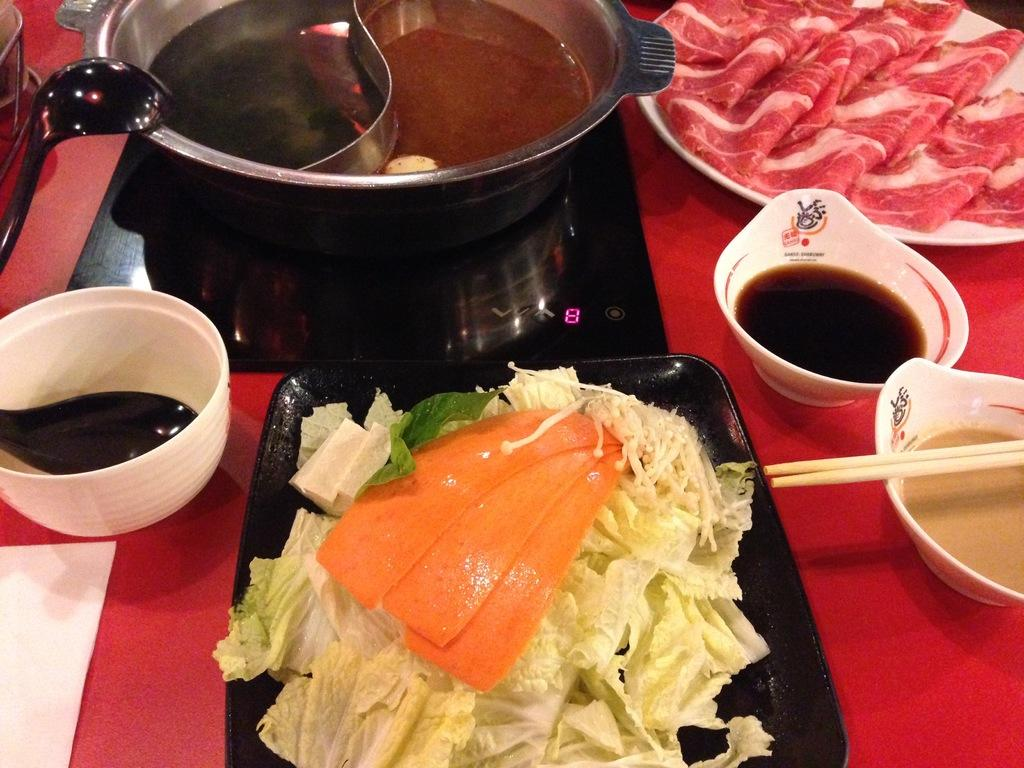What type of utensils can be seen on the table in the image? Spoons and chopsticks are visible on the table in the image. What type of dishware is present on the table? Bowls and plates are present on the table. What is on the paper on the table? The provided facts do not mention anything about the paper on the table. What type of food is in the bowl? There is soup in a bowl. What type of food is on the white plate? There is meat on a white plate. What is the acoustics of the soup in the bowl like in the image? The provided facts do not mention anything about the acoustics of the soup in the image. How many balls are visible on the table in the image? There are no balls visible on the table in the image. 